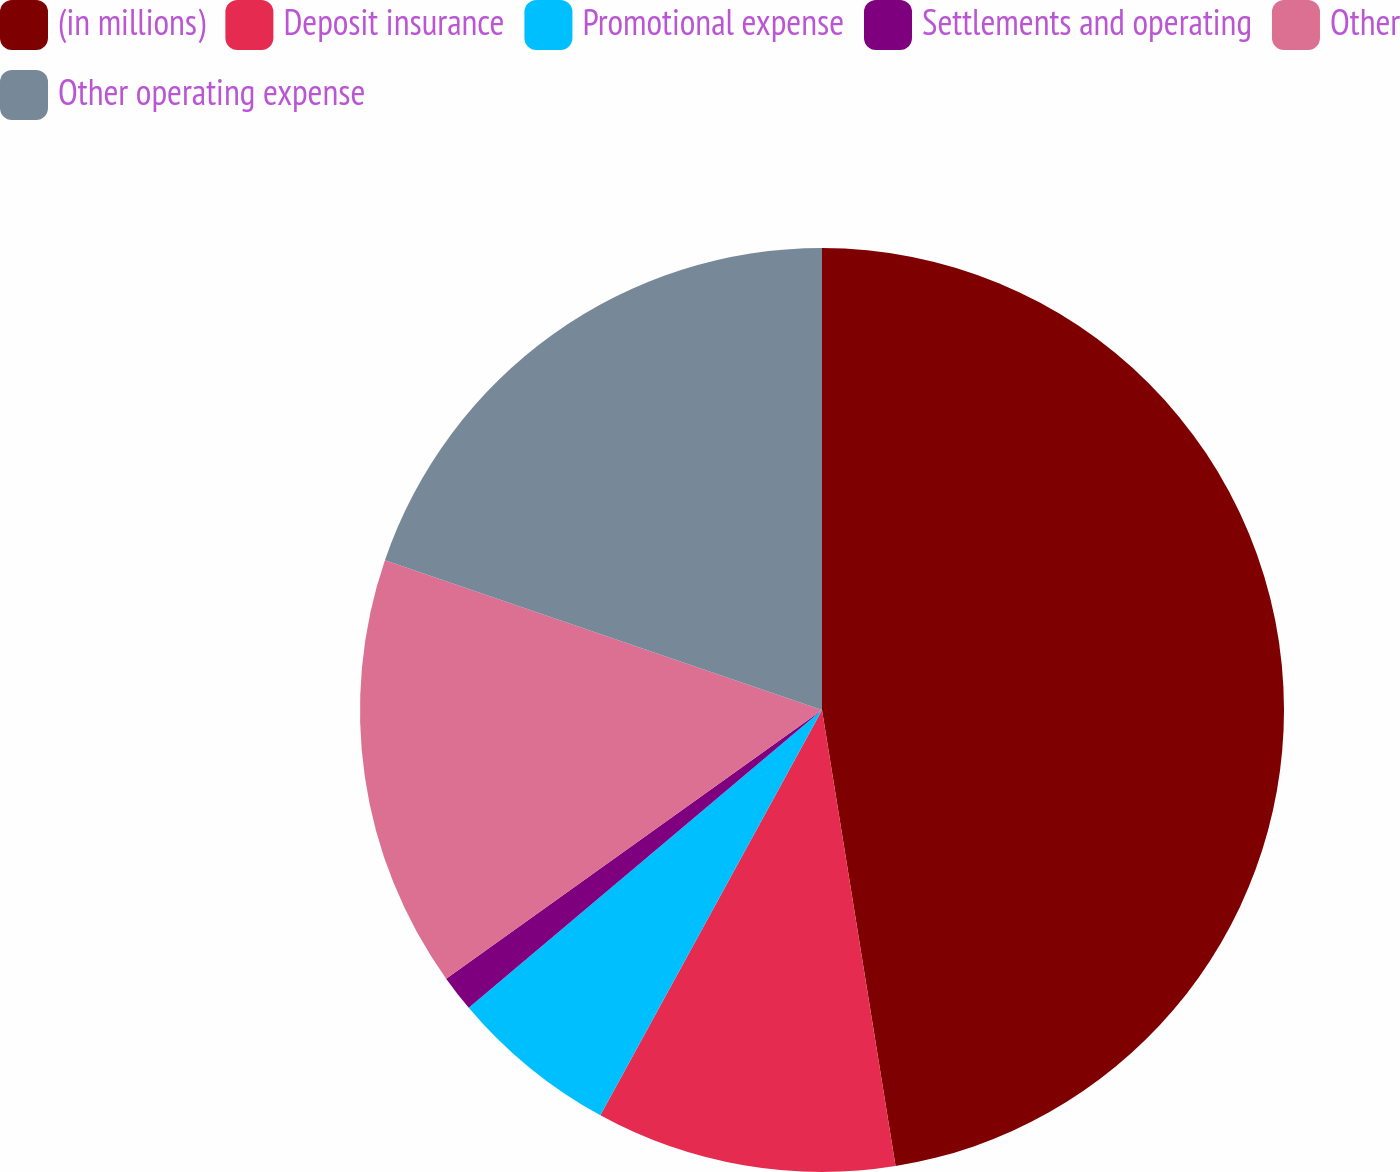<chart> <loc_0><loc_0><loc_500><loc_500><pie_chart><fcel>(in millions)<fcel>Deposit insurance<fcel>Promotional expense<fcel>Settlements and operating<fcel>Other<fcel>Other operating expense<nl><fcel>47.46%<fcel>10.51%<fcel>5.89%<fcel>1.27%<fcel>15.13%<fcel>19.75%<nl></chart> 